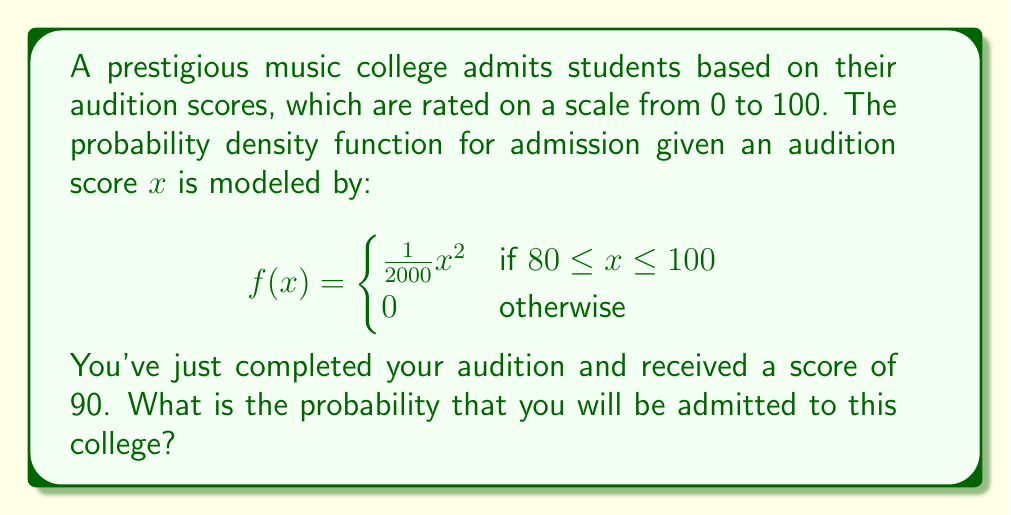Provide a solution to this math problem. To solve this problem, we need to integrate the probability density function from the given score (90) to the maximum possible score (100). This will give us the probability of being admitted with a score of 90 or higher.

1) First, let's verify that this is a valid probability density function by integrating it over its entire domain:

   $$\int_{80}^{100} \frac{1}{2000}x^2 dx = \frac{1}{2000}[\frac{1}{3}x^3]_{80}^{100} = \frac{1}{6000}(1000000 - 512000) = 1$$

   This confirms that it's a valid PDF.

2) Now, we need to calculate the probability of admission given a score of 90:

   $$P(X \geq 90) = \int_{90}^{100} \frac{1}{2000}x^2 dx$$

3) Let's solve this integral:

   $$\int_{90}^{100} \frac{1}{2000}x^2 dx = \frac{1}{2000}[\frac{1}{3}x^3]_{90}^{100}$$

4) Evaluating the antiderivative:

   $$\frac{1}{2000}(\frac{1}{3} \cdot 100^3 - \frac{1}{3} \cdot 90^3) = \frac{1}{6000}(1000000 - 729000)$$

5) Simplifying:

   $$\frac{1}{6000} \cdot 271000 = \frac{271}{6} \approx 45.1667$$

Therefore, the probability of admission with a score of 90 is approximately 0.4517 or 45.17%.
Answer: The probability of admission with an audition score of 90 is approximately 0.4517 or 45.17%. 